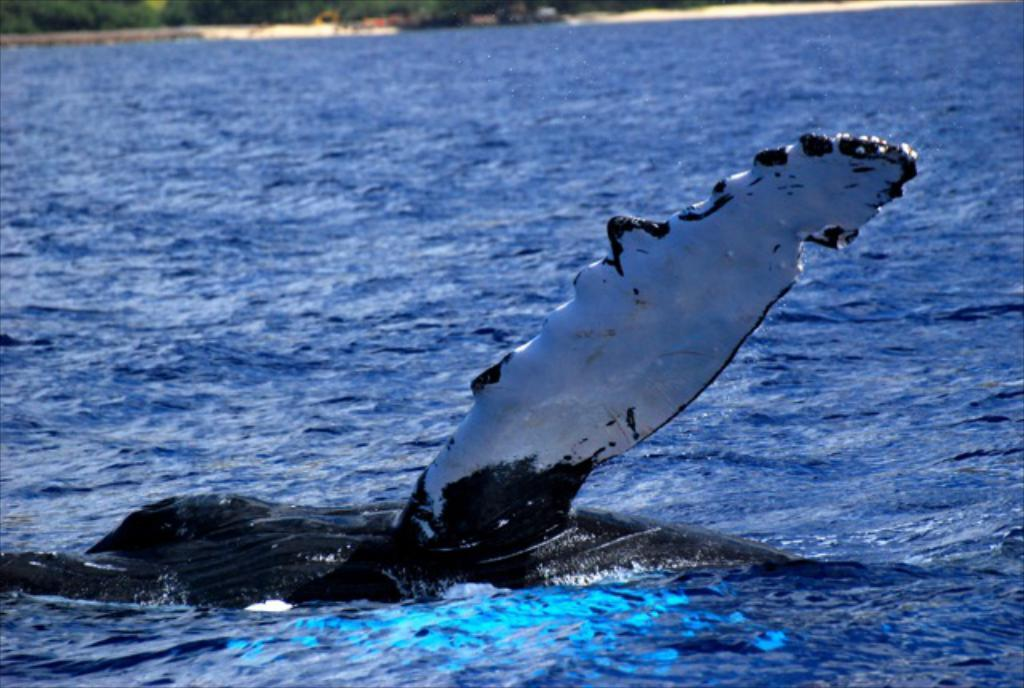What is the color of the object in the image? The object in the image is white and black in color. Where is the object located in the image? The object is in the water. What color is the water in the image? The water is blue in color. What can be seen in the background of the image? The background of the image includes trees. What color are the trees in the image? The trees are green in color. Can you see any wounds on the trees in the image? There is no mention of any wounds on the trees in the image, and therefore we cannot determine if any are present. 